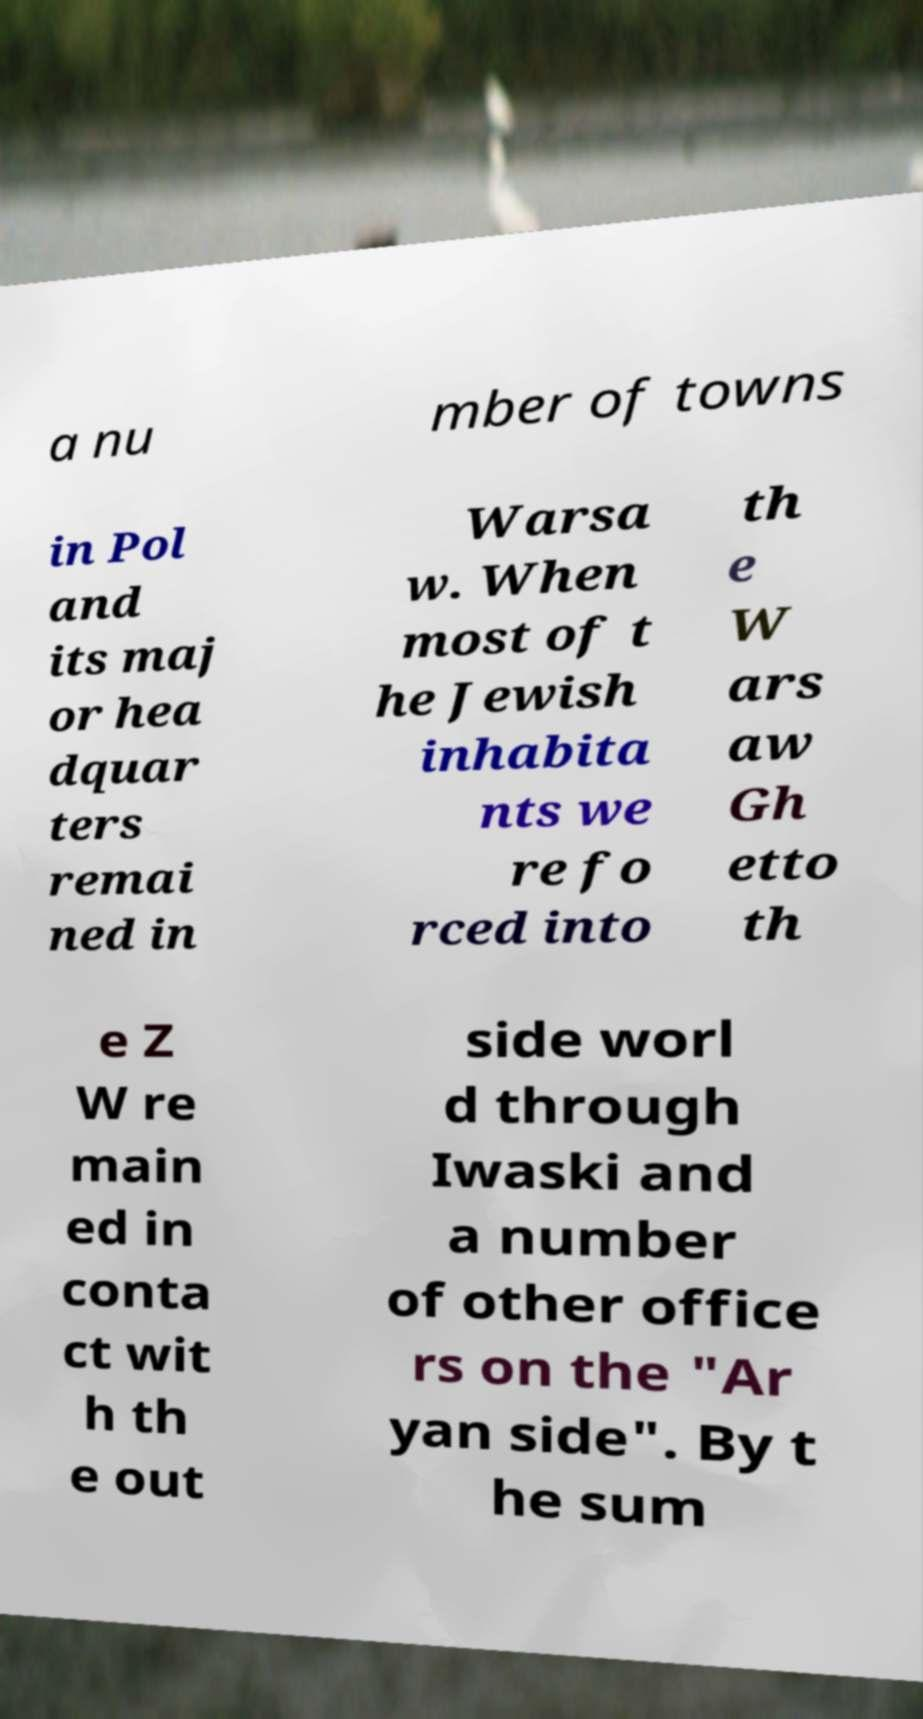Can you accurately transcribe the text from the provided image for me? a nu mber of towns in Pol and its maj or hea dquar ters remai ned in Warsa w. When most of t he Jewish inhabita nts we re fo rced into th e W ars aw Gh etto th e Z W re main ed in conta ct wit h th e out side worl d through Iwaski and a number of other office rs on the "Ar yan side". By t he sum 